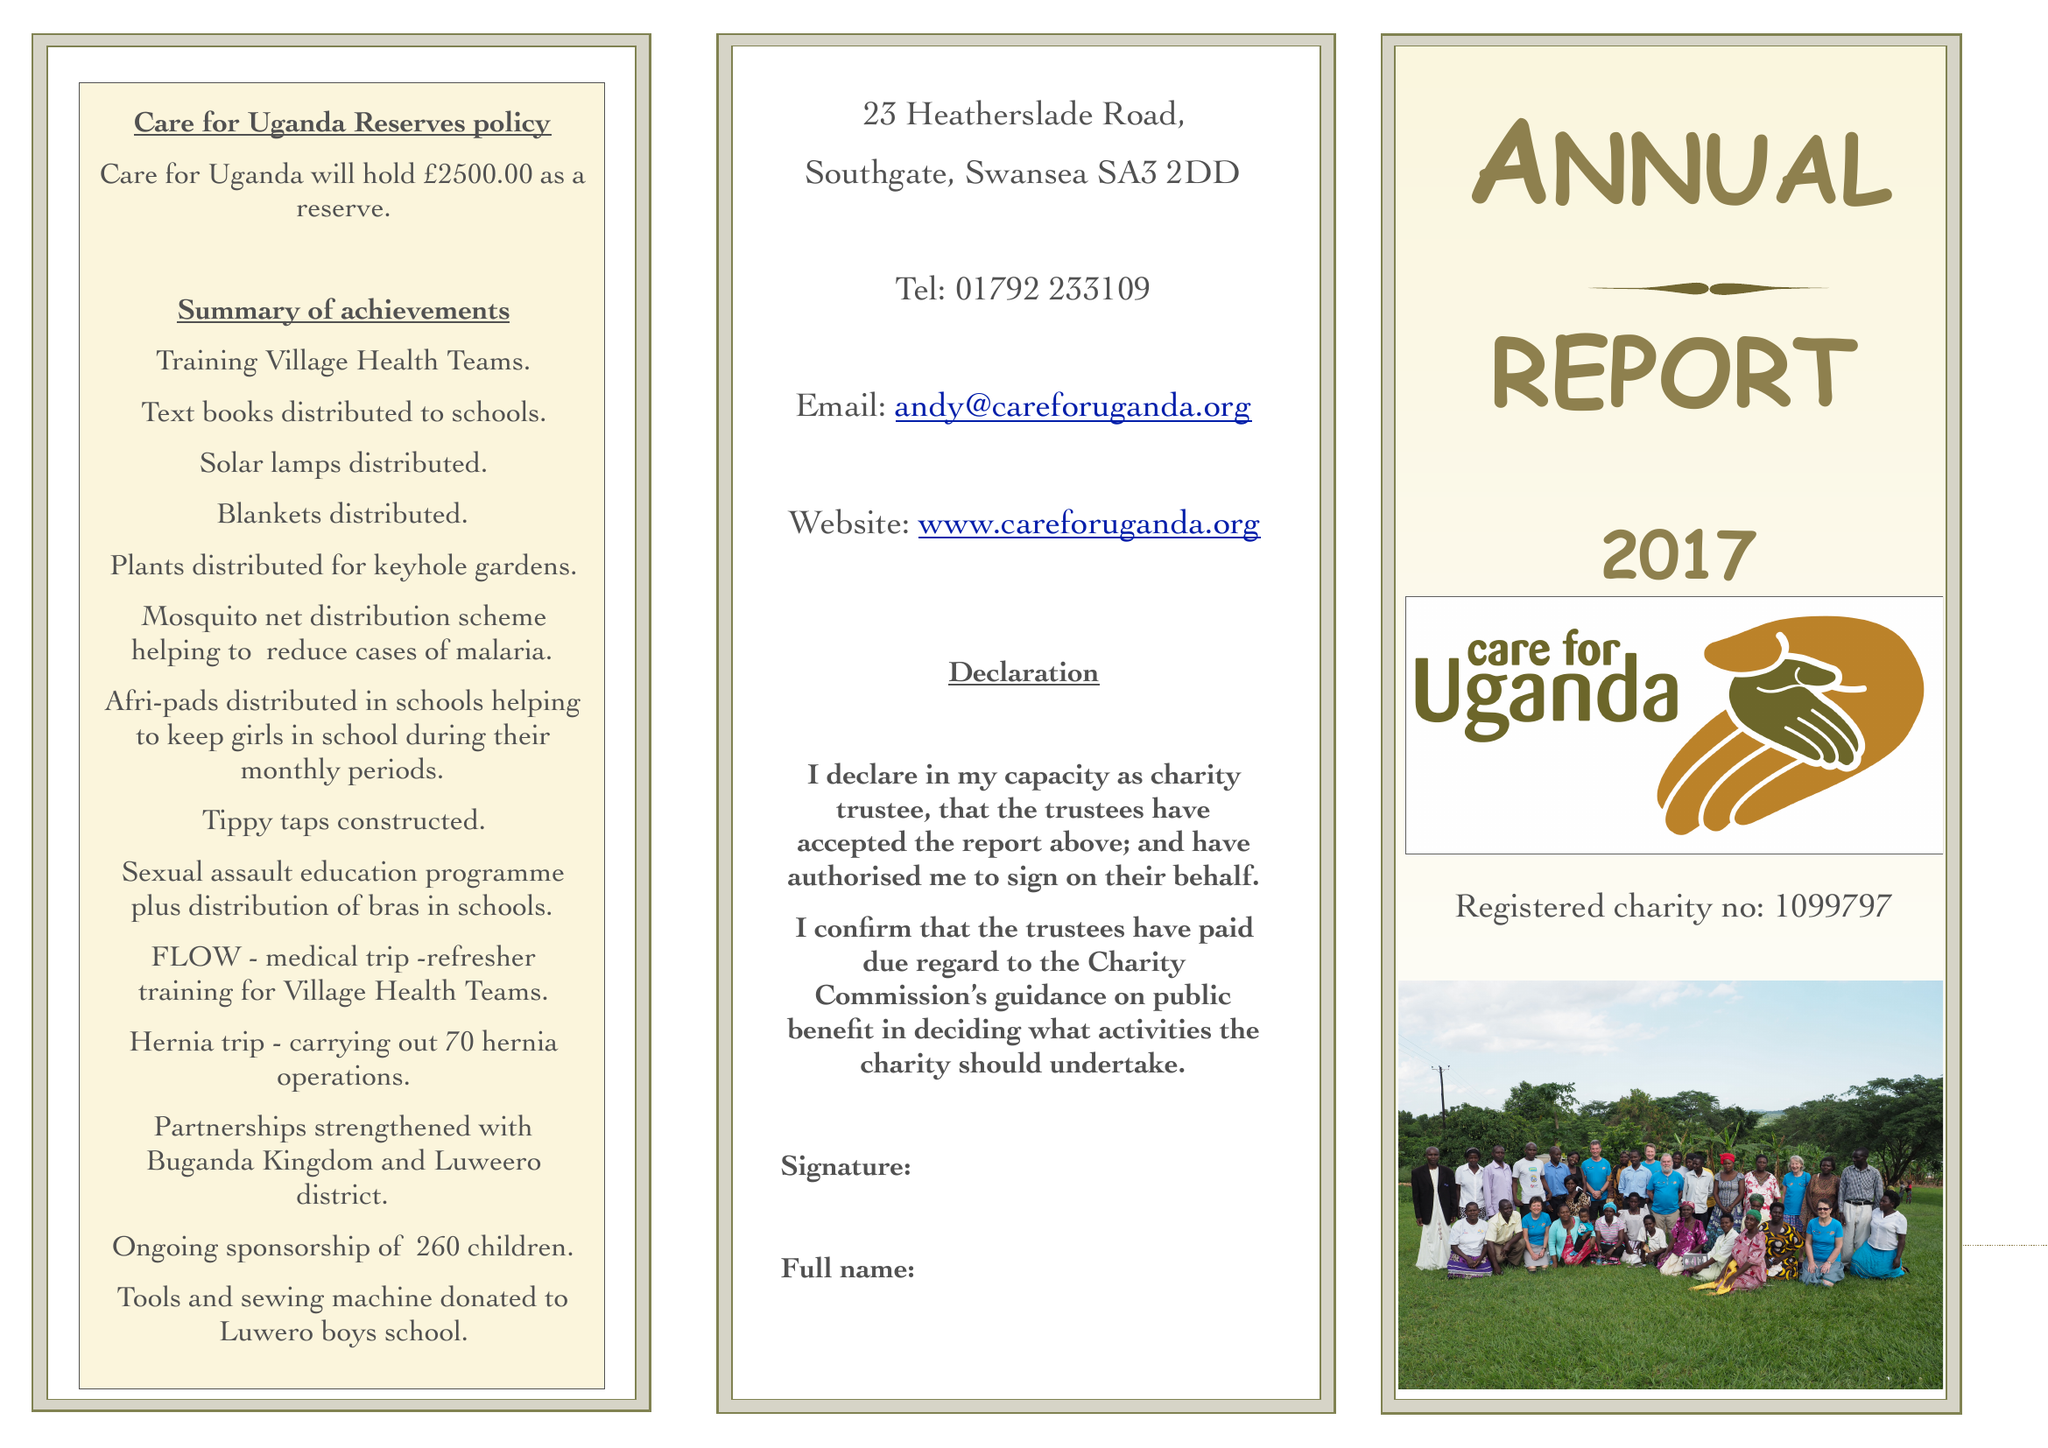What is the value for the address__postcode?
Answer the question using a single word or phrase. SA3 2DD 